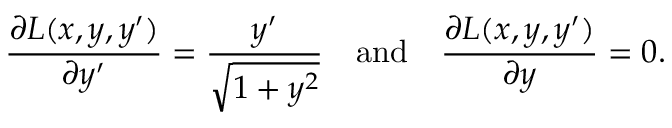Convert formula to latex. <formula><loc_0><loc_0><loc_500><loc_500>{ \frac { \partial L ( x , y , y ^ { \prime } ) } { \partial y ^ { \prime } } } = { \frac { y ^ { \prime } } { \sqrt { 1 + y ^ { 2 } } } } \quad a n d \quad \frac { \partial L ( x , y , y ^ { \prime } ) } { \partial y } = 0 .</formula> 